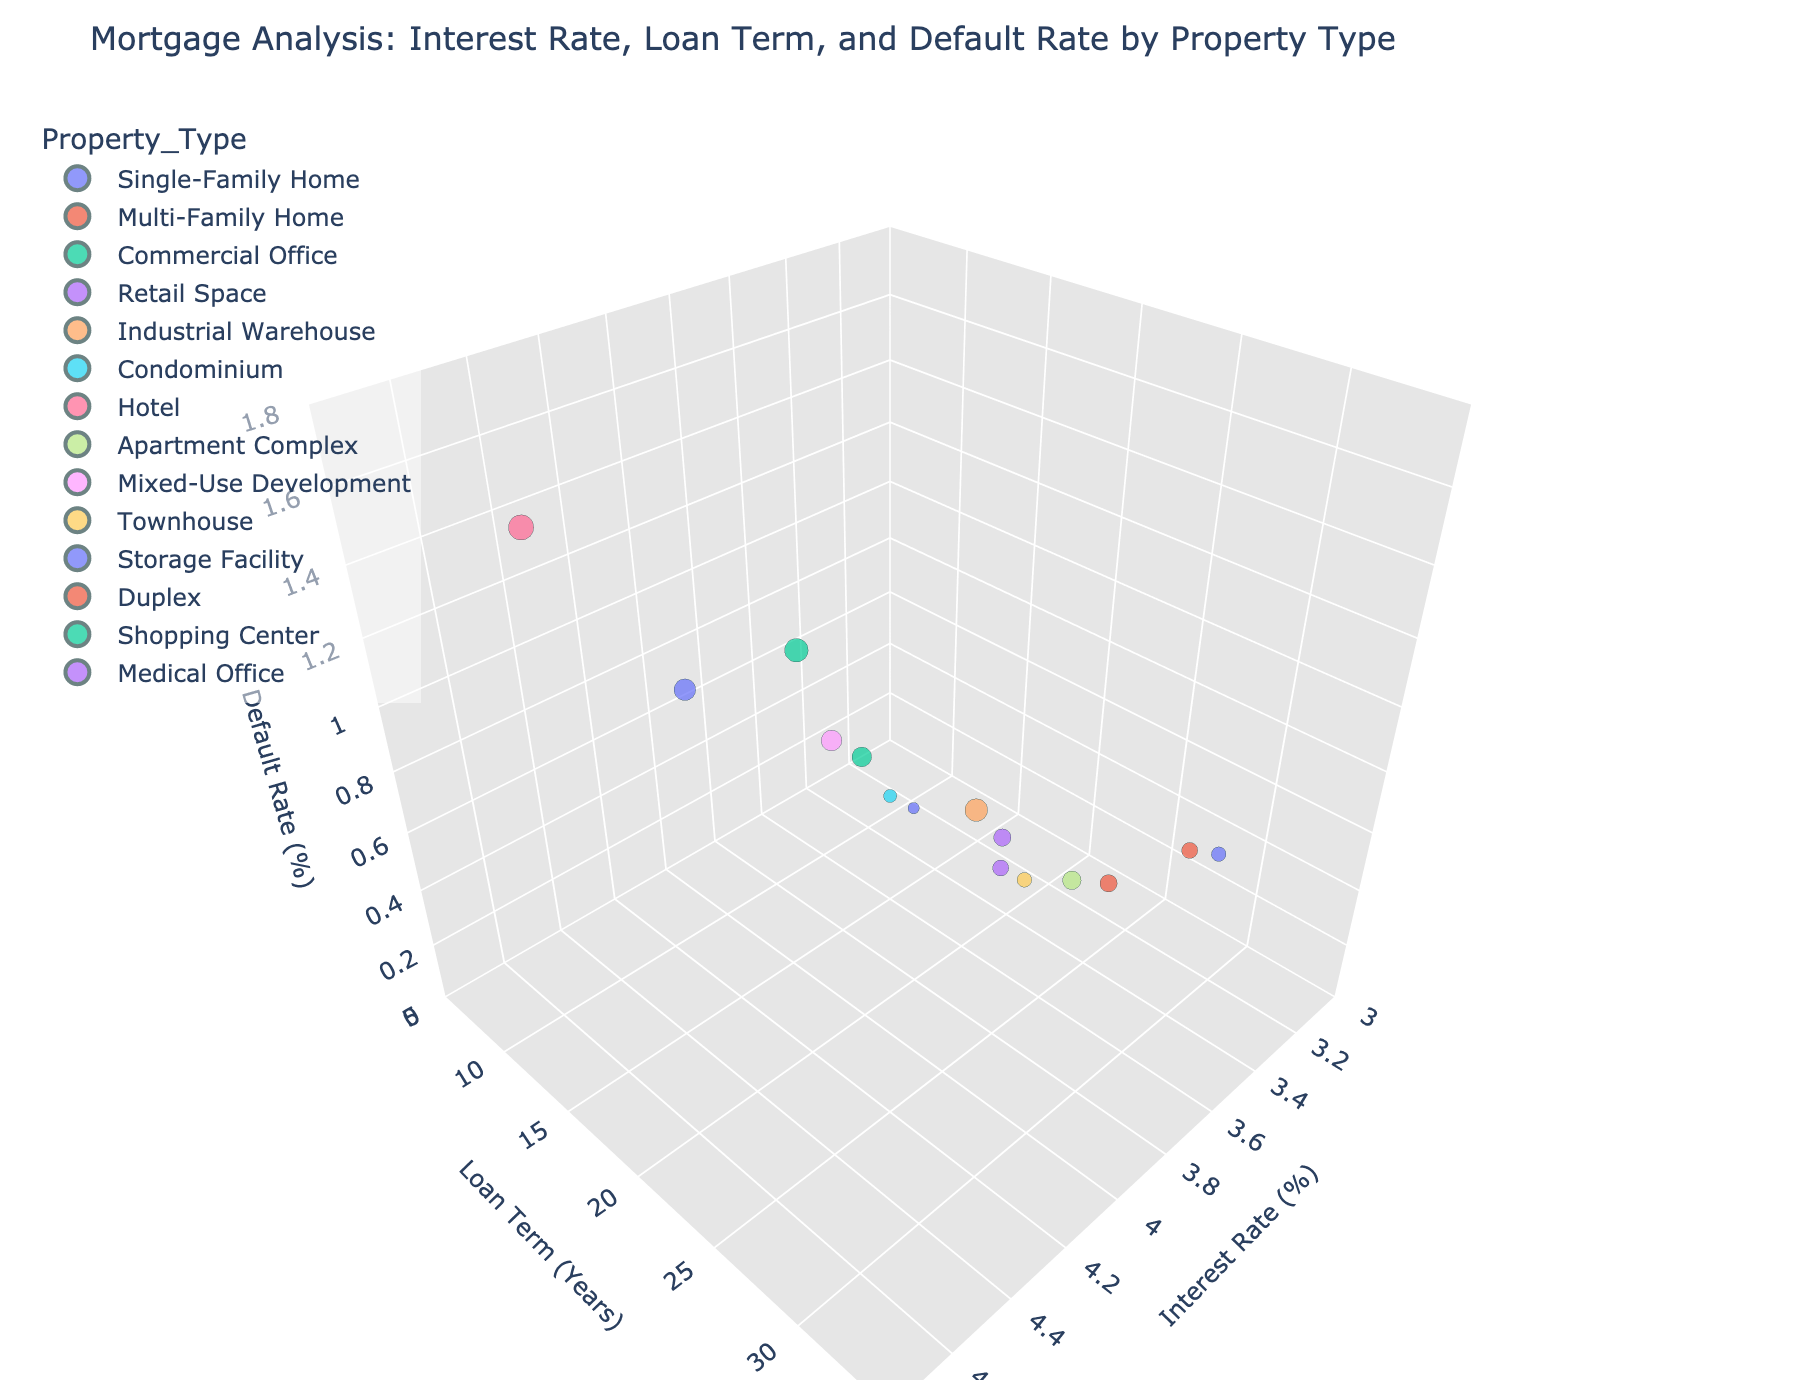What is the title of the figure? The title of the figure is usually displayed at the top of the plot. By looking at the top, we can see the text that serves as the title of the figure.
Answer: Mortgage Analysis: Interest Rate, Loan Term, and Default Rate by Property Type Which property type has the highest default rate? Identify the point with the highest value on the default rate axis, which is the z-axis. Use the color and hover information to verify the property type.
Answer: Hotel Which property type has the lowest mortgage interest rate? Locate the point with the lowest value on the mortgage interest rate axis, which is the x-axis. Use the color and hover information to verify the property type.
Answer: Single-Family Home How many property types have a loan term of 30 years? Count the number of points that align with the value 30 on the loan term axis, which is the y-axis.
Answer: 5 What is the default rate for Commercial Office properties? Hover over the point corresponding to "Commercial Office" to read its default rate from the plot's hover information.
Answer: 0.9 What is the range of mortgage interest rates for the properties shown? Look at the x-axis to identify the minimum and maximum mortgage interest rates. The axes' range should show the span of these interest rates.
Answer: 3.25 to 4.5 Which property type has a 15-year loan term and what is its default rate? Locate the points on the y-axis at 15 years, then use the hover information to identify each property's type and default rate.
Answer: Single-Family Home: 0.3, Condominium: 0.4, Storage Facility: 1.1 What is the median default rate for properties with a loan term of 25 years? First, locate the points at 25 years on the y-axis. Note their default rates (0.5, 0.6, 0.7). To find the median, sort and take the middle value.
Answer: 0.6 Compare the default rates for Retail Space and Apartment Complex properties. Which one is higher? Locate points for both Retail Space and Apartment Complex. Check the z-axis values for both points and compare them.
Answer: Apartment Complex How does the default rate change as the mortgage interest rate increases from 3.25% to 4.5%? Trace along the x-axis from 3.25% to 4.5% and observe the default rate (z-axis) values at various interest rates. Describe the trend.
Answer: Generally increases Is there any property type with a default rate higher than 1.0% that does not have a 30-year loan term? If so, which one? Identify points with a default rate above 1.0% on the z-axis, then check their loan terms (y-axis) to see if they are not 30 years.
Answer: Yes, Storage Facility (15 years), Shopping Center (20 years) 